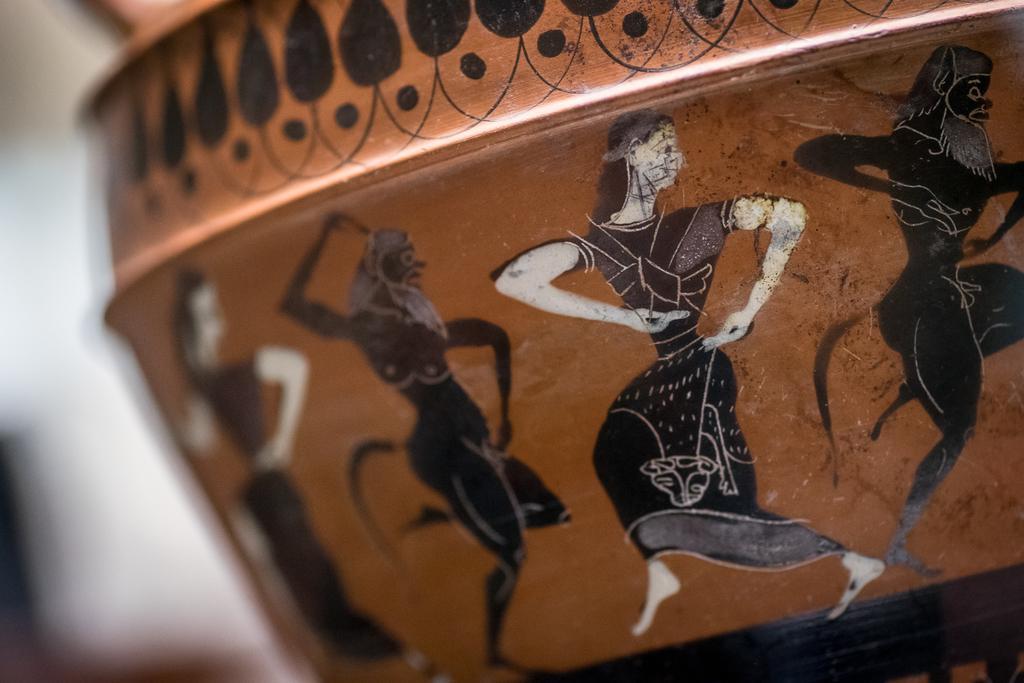Please provide a concise description of this image. In the foreground of this image, there are paintings and it seems like those paintings are on the pot. 